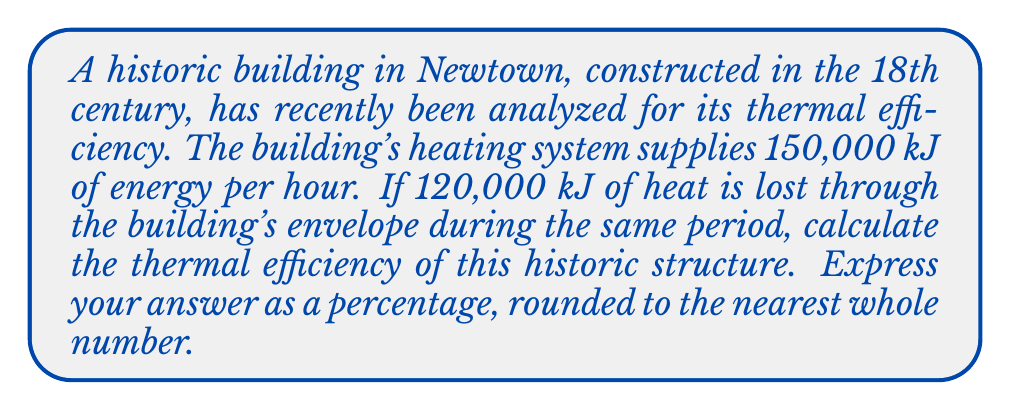Give your solution to this math problem. To calculate the thermal efficiency of the historic Newtown building, we need to follow these steps:

1. Identify the given information:
   - Energy supplied by the heating system: 150,000 kJ/hour
   - Heat lost through the building envelope: 120,000 kJ/hour

2. Determine the formula for thermal efficiency:
   Thermal efficiency is defined as the ratio of useful energy output to the total energy input, expressed as a percentage.

   $$ \text{Thermal Efficiency} = \frac{\text{Useful Energy Output}}{\text{Total Energy Input}} \times 100\% $$

3. Calculate the useful energy output:
   Useful energy is the difference between the energy supplied and the energy lost.
   $$ \text{Useful Energy} = \text{Energy Supplied} - \text{Energy Lost} $$
   $$ \text{Useful Energy} = 150,000 \text{ kJ} - 120,000 \text{ kJ} = 30,000 \text{ kJ} $$

4. Apply the thermal efficiency formula:
   $$ \text{Thermal Efficiency} = \frac{30,000 \text{ kJ}}{150,000 \text{ kJ}} \times 100\% $$

5. Perform the calculation:
   $$ \text{Thermal Efficiency} = 0.2 \times 100\% = 20\% $$

6. Round to the nearest whole number:
   The thermal efficiency is already a whole number, so no rounding is necessary.

Therefore, the thermal efficiency of the historic Newtown building is 20%.
Answer: 20% 